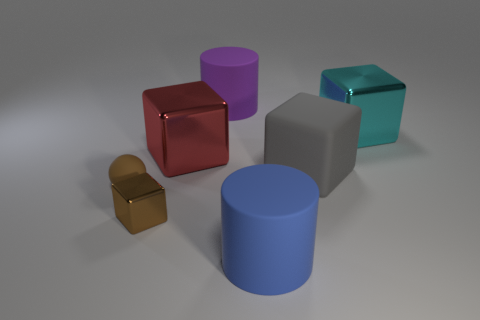Are there any cubes that have the same size as the blue matte cylinder?
Provide a succinct answer. Yes. Do the blue thing left of the cyan shiny block and the red thing have the same size?
Provide a short and direct response. Yes. Are there more big shiny cubes than large brown rubber cubes?
Offer a terse response. Yes. Are there any other rubber things that have the same shape as the blue object?
Your answer should be compact. Yes. The matte object left of the large purple rubber thing has what shape?
Make the answer very short. Sphere. How many metal objects are behind the big shiny cube on the right side of the big gray matte cube that is behind the big blue matte thing?
Offer a terse response. 0. There is a tiny block that is on the left side of the blue matte thing; does it have the same color as the rubber ball?
Your response must be concise. Yes. How many other things are the same shape as the tiny matte object?
Give a very brief answer. 0. What number of other things are there of the same material as the gray block
Offer a very short reply. 3. There is a big thing that is to the left of the matte cylinder that is behind the large thing that is to the right of the gray rubber block; what is its material?
Ensure brevity in your answer.  Metal. 